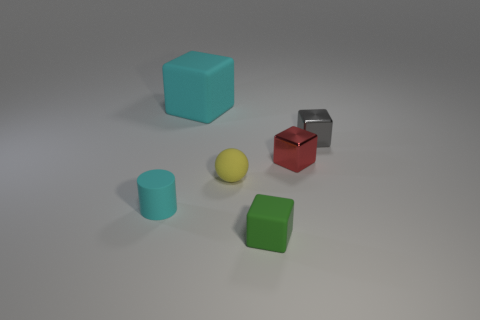The cyan object that is on the right side of the matte thing that is left of the big cube is made of what material?
Keep it short and to the point. Rubber. The gray object that is the same shape as the red shiny object is what size?
Provide a short and direct response. Small. Is the color of the tiny rubber ball the same as the small rubber cylinder?
Make the answer very short. No. What is the color of the tiny rubber object that is in front of the small yellow thing and to the right of the cyan block?
Your answer should be compact. Green. There is a red metallic block that is in front of the gray block; is it the same size as the small yellow thing?
Provide a short and direct response. Yes. Are there any other things that are the same shape as the small red thing?
Your response must be concise. Yes. Is the material of the gray block the same as the cyan object in front of the cyan matte block?
Your response must be concise. No. How many green things are either small shiny things or small cylinders?
Keep it short and to the point. 0. Are there any red metallic blocks?
Provide a succinct answer. Yes. There is a matte block that is on the right side of the cyan object that is behind the small cyan rubber thing; is there a big cyan matte block that is right of it?
Ensure brevity in your answer.  No. 